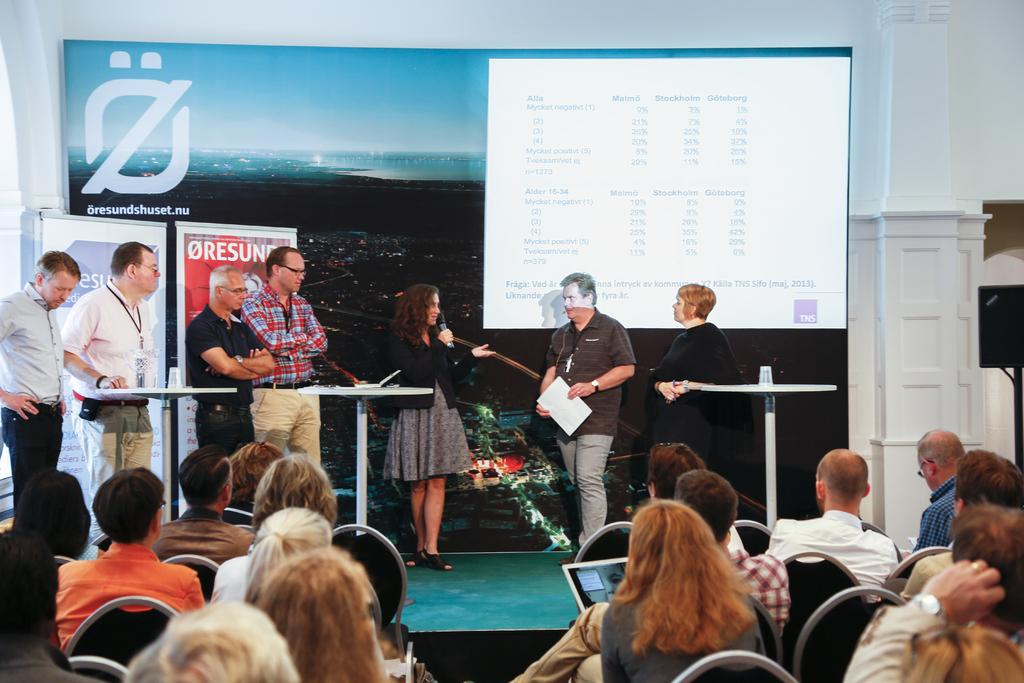What are the people on the stage doing? The people on the stage are standing. What are the people in front of the stage doing? The people in front of the stage are sitting in chairs. What is the relationship between the people on the stage and the seated people? The seated people are looking at the people on the stage. What type of insurance policy do the people on the stage have? There is no information about insurance policies in the image, as it focuses on people standing on a stage and seated people looking at them. 